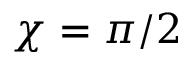Convert formula to latex. <formula><loc_0><loc_0><loc_500><loc_500>\chi = \pi / 2</formula> 